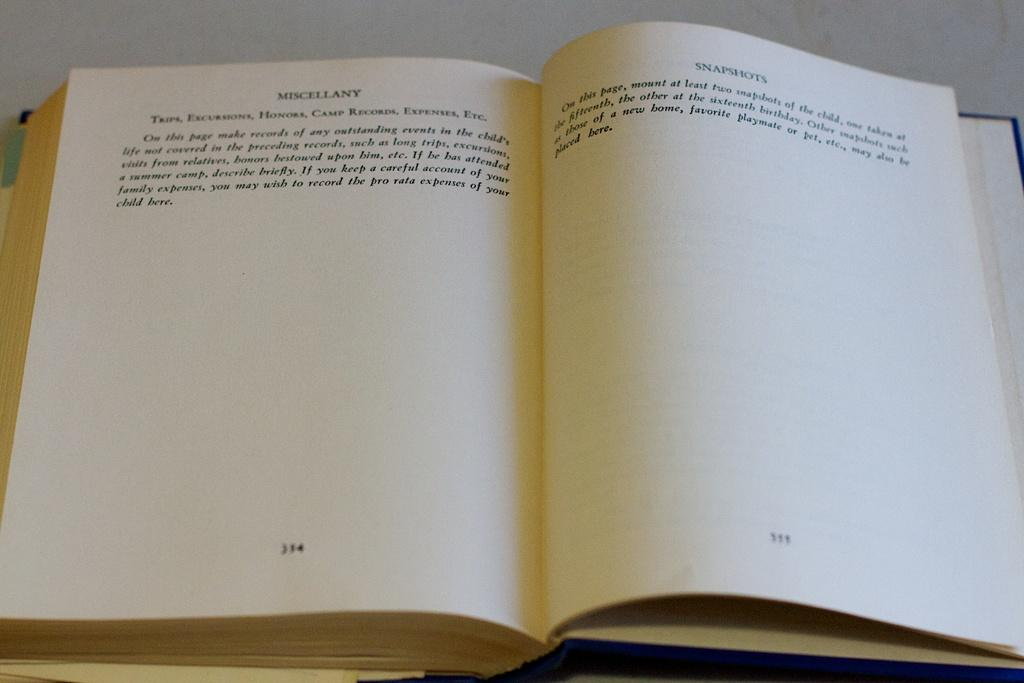<image>
Describe the image concisely. A book opened that reads Miscellany and Snapshots on the top of the pages. 